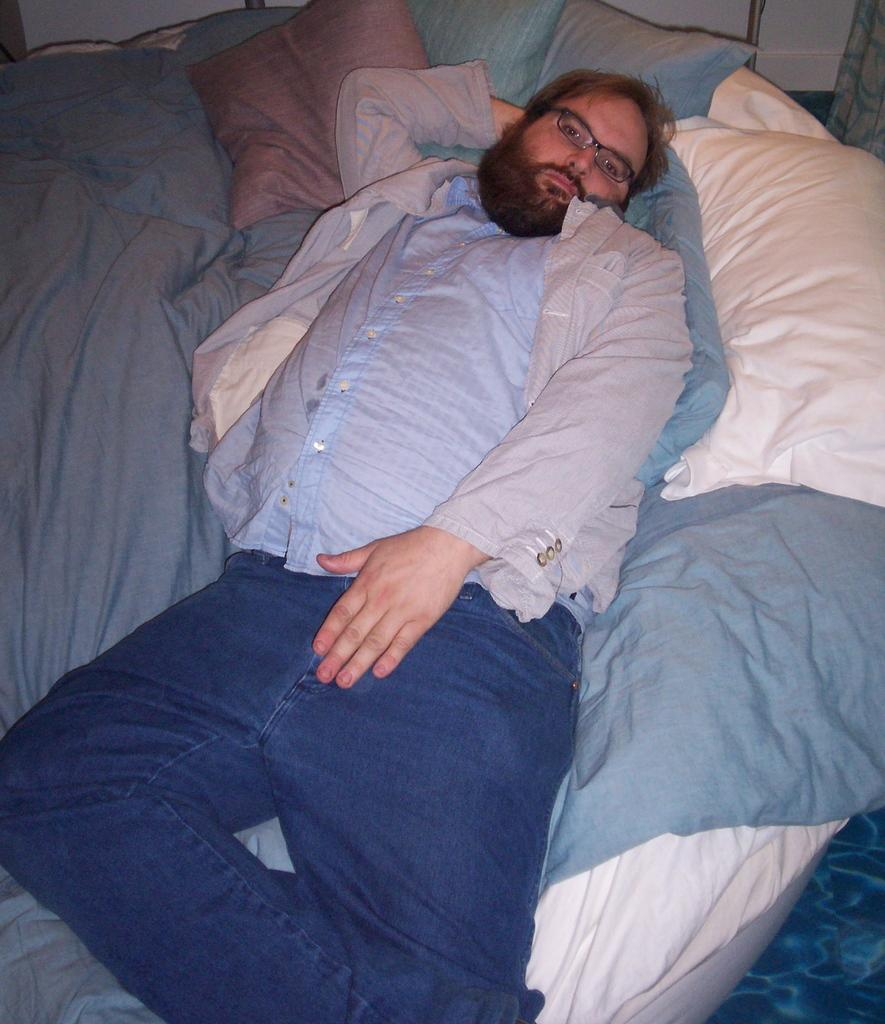Who is present in the image? There is a man in the image. What is the man doing in the image? The man is sleeping on a bed in the image. What type of clothing is the man wearing? The man is wearing a shirt and trousers in the image. What accessory is the man wearing in the image? The man is wearing spectacles in the image. What type of poison is the man using in the image? There is no poison present in the image; the man is simply sleeping on a bed. 